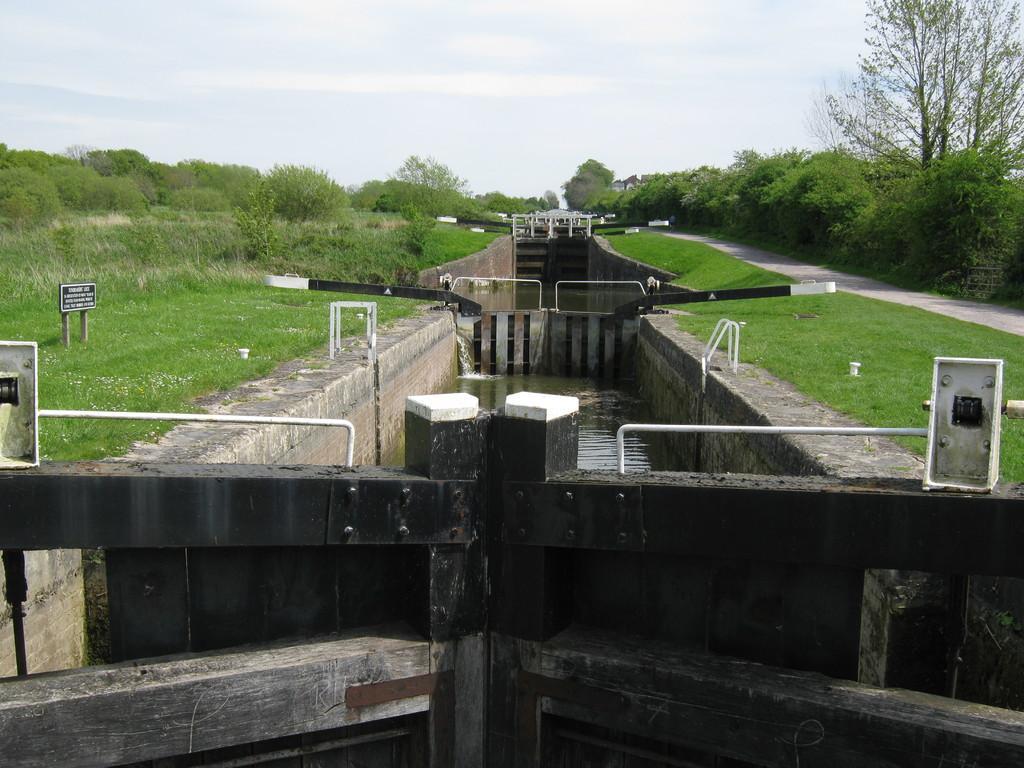Describe this image in one or two sentences. In the middle of the picture we can see gates and a water body. On the left there are trees, plants and grass. On the right there are trees and a path. In the center of the background there are trees. At the top there is sky. 